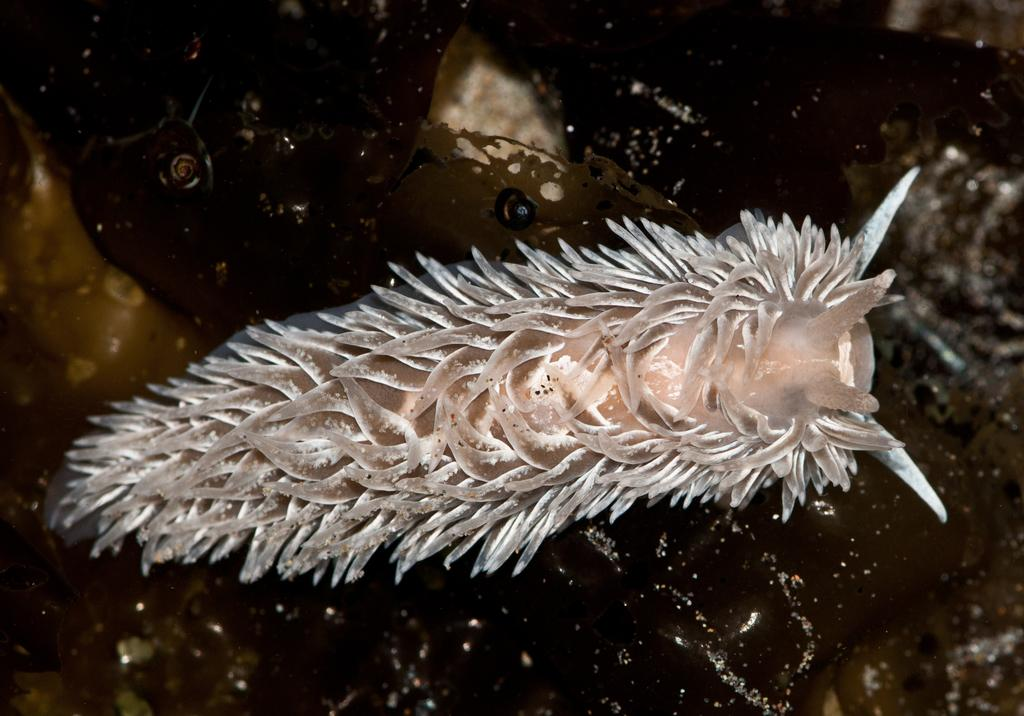What is the main subject of the image? There is an insect in the middle of the image. Can you describe the background of the image? The background of the image has black and yellow colors. What type of mist can be seen surrounding the owl in the image? There is no owl present in the image, and therefore no mist surrounding it. 